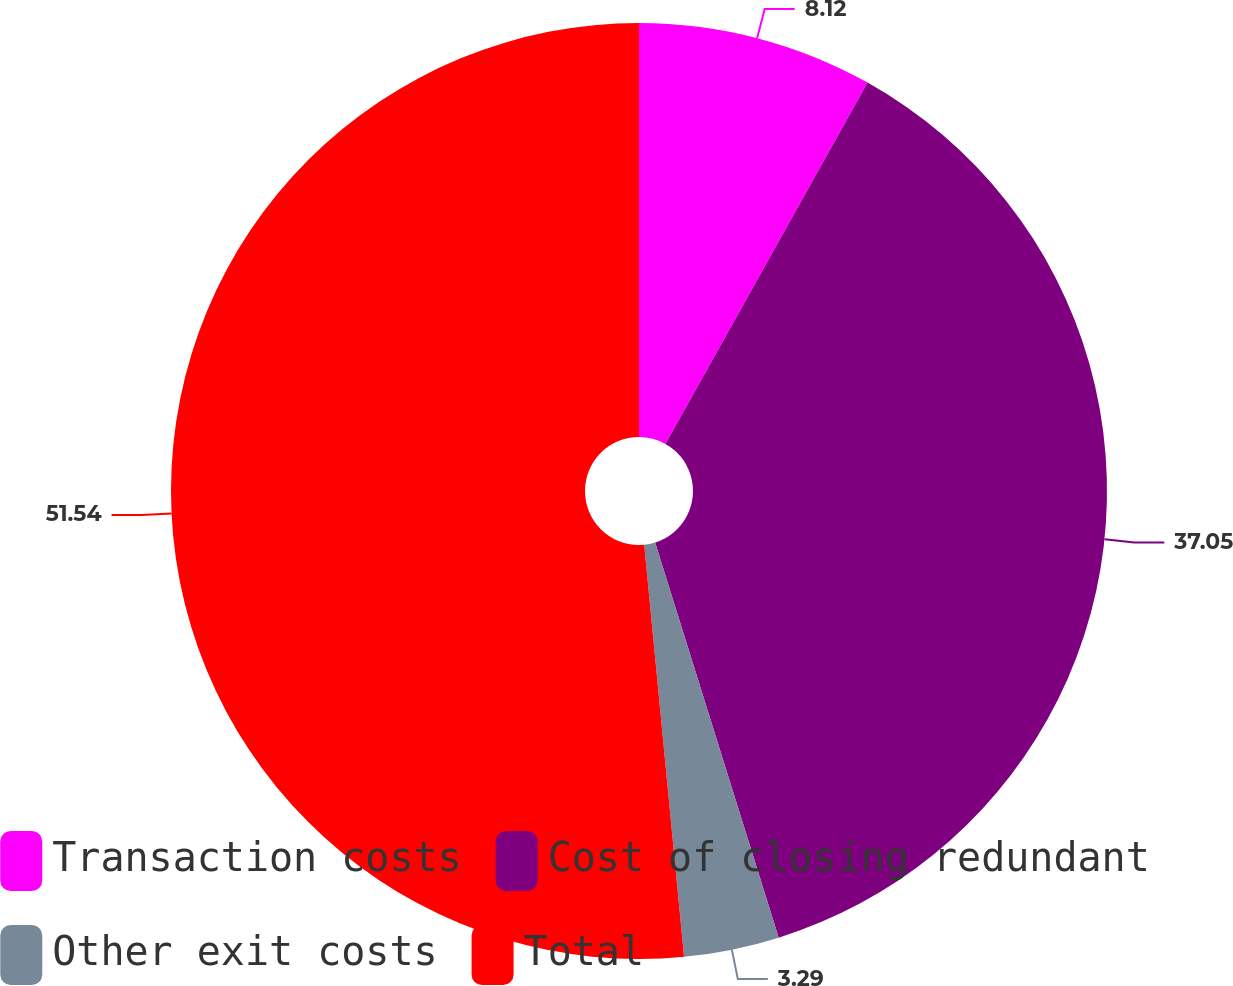Convert chart. <chart><loc_0><loc_0><loc_500><loc_500><pie_chart><fcel>Transaction costs<fcel>Cost of closing redundant<fcel>Other exit costs<fcel>Total<nl><fcel>8.12%<fcel>37.05%<fcel>3.29%<fcel>51.53%<nl></chart> 